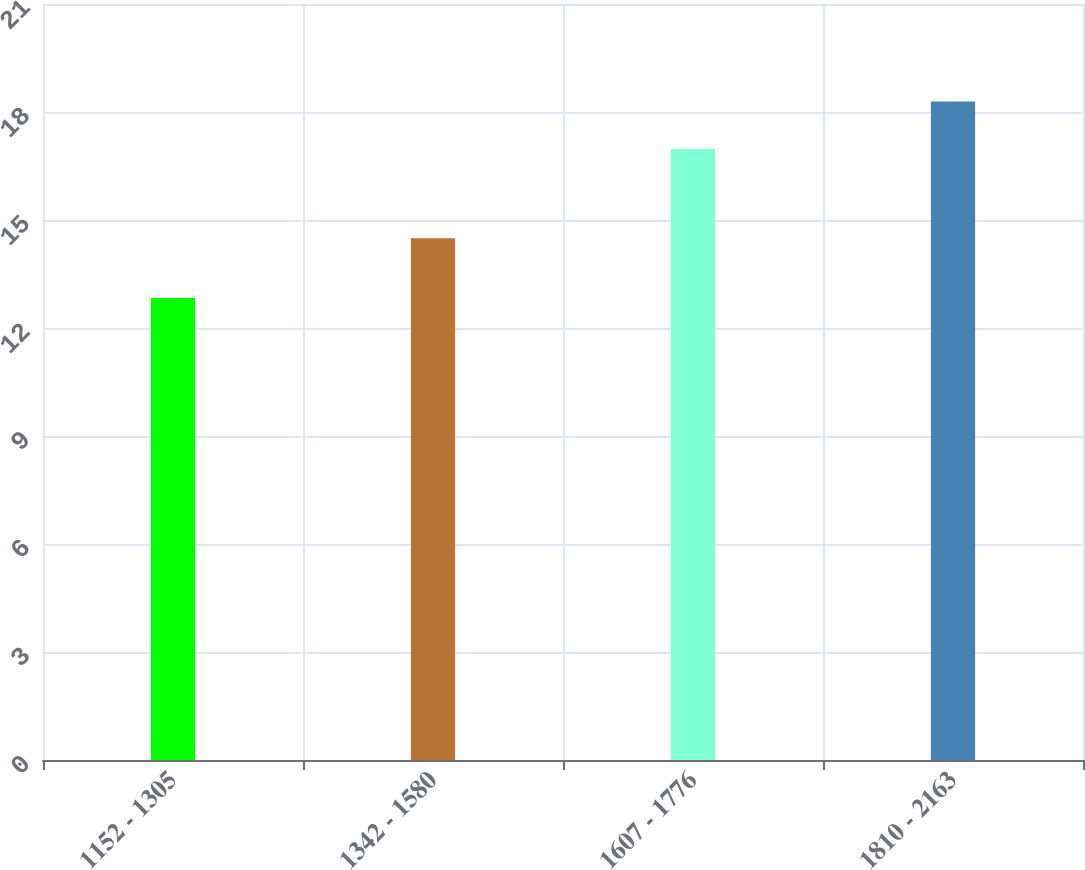Convert chart. <chart><loc_0><loc_0><loc_500><loc_500><bar_chart><fcel>1152 - 1305<fcel>1342 - 1580<fcel>1607 - 1776<fcel>1810 - 2163<nl><fcel>12.83<fcel>14.49<fcel>16.97<fcel>18.29<nl></chart> 